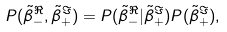<formula> <loc_0><loc_0><loc_500><loc_500>P ( \tilde { \beta } _ { - } ^ { \Re } , \tilde { \beta } _ { + } ^ { \Im } ) = P ( \tilde { \beta } _ { - } ^ { \Re } | \tilde { \beta } _ { + } ^ { \Im } ) P ( \tilde { \beta } _ { + } ^ { \Im } ) ,</formula> 